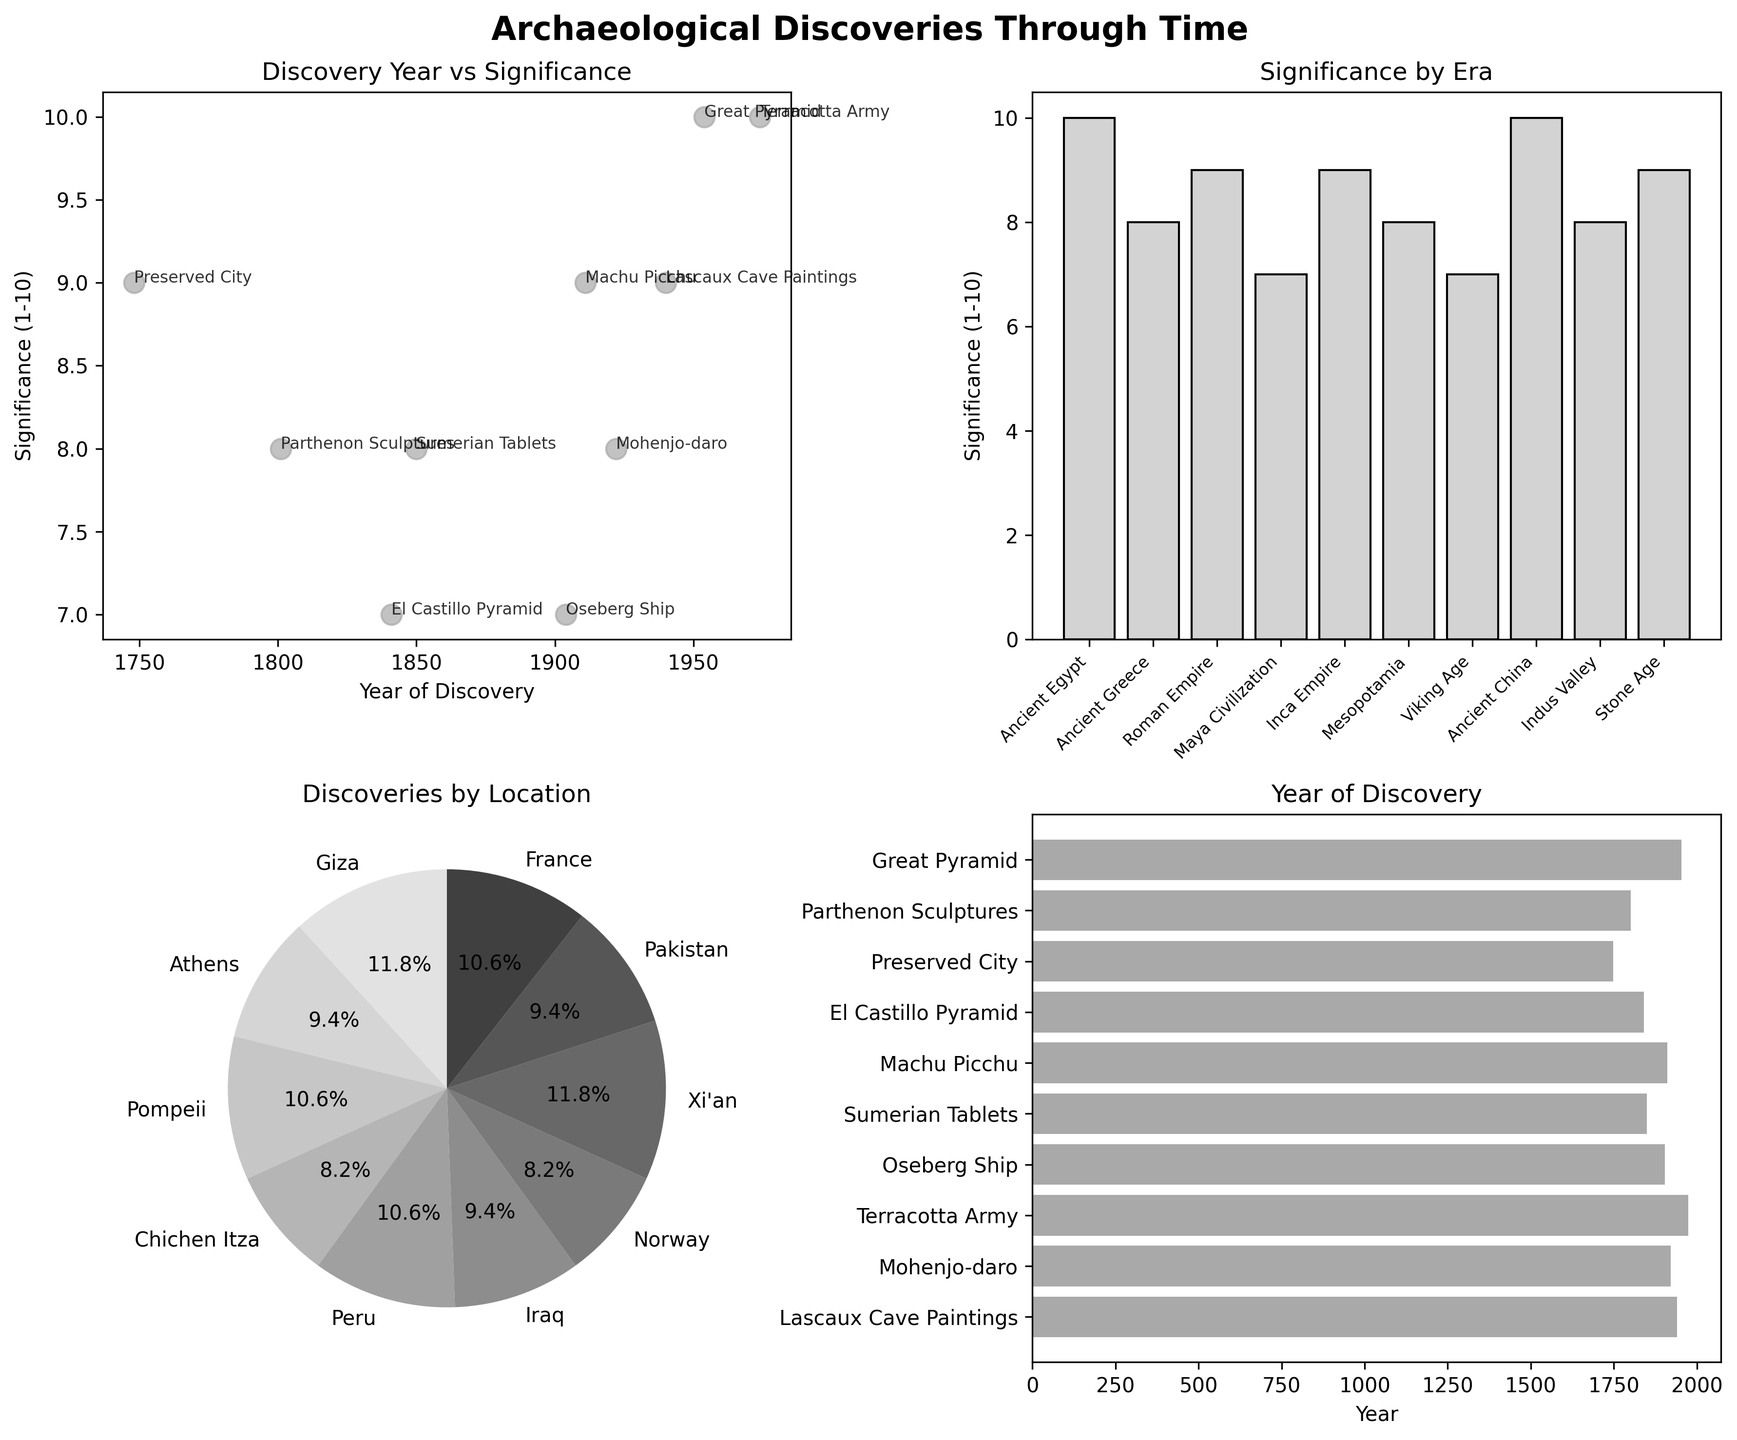how many plots are there in total? The figure consists of a 2x2 grid of subplots, resulting in a total of 4 plots.
Answer: 4 plots Which discovery has the highest significance? By examining the scatter plot in the top-left subplot, where significance is plotted against the year of discovery, it is clear that two discoveries have the highest significance with a score of 10. These are the Great Pyramid and the Terracotta Army.
Answer: Great Pyramid and Terracotta Army What is the time range of the archaeological discoveries shown? By looking at the horizontal bar chart in the bottom-right subplot, we can see that the earliest discovery is from 1748 and the latest is from 1974. The range is from 1748 to 1974.
Answer: 1748 - 1974 Which era has the least significant discovery? By examining the bar plot of significance by era in the top-right subplot, it is clear that the Maya Civilization and Viking Age both have discoveries with the lowest significance score of 7.
Answer: Maya Civilization and Viking Age Which location contributed the most to the pie chart? In the pie chart on the bottom-left subplot, which shows discoveries by location, the slice with the largest percentage represents the locations with the highest significance scores. The largest contributions are from Giza (Great Pyramid) and Xi'an (Terracotta Army), both contributing significantly due to their highest significance score of 10.
Answer: Giza and Xi'an What is the approximate percentage of significance contributed by the Roman Empire's discovery? In the pie chart in the bottom-left subplot, each slice size represents the significance of each discovery. The preserved city of Pompeii has a significance of 9, which appears to take about 10% of the pie chart due to other discoveries having similar ranges of significance values.
Answer: Approximately 10% Which discovery took place closest to the year 1900? By examining the scatter plot of 'Year vs Significance' in the top-left subplot, it can be noted that Mohenjo-daro was discovered in 1922, which is closest to the year 1900 compared to the other discoveries.
Answer: Mohenjo-daro What is the average significance of all the discoveries shown in the plots? Adding up all the significance values, we get 86 (10+8+9+7+9+8+7+10+8+9). There are 10 discoveries, so the average significance is 86 / 10 = 8.6.
Answer: 8.6 Which discovery is older, the Great Pyramid or the Lascaux Cave Paintings? By observing the horizontal bar chart in the bottom-right subplot, we see that the Great Pyramid was discovered in 1954, whereas the Lascaux Cave Paintings were discovered in 1940. Thus, the Lascaux Cave Paintings are older.
Answer: Lascaux Cave Paintings 